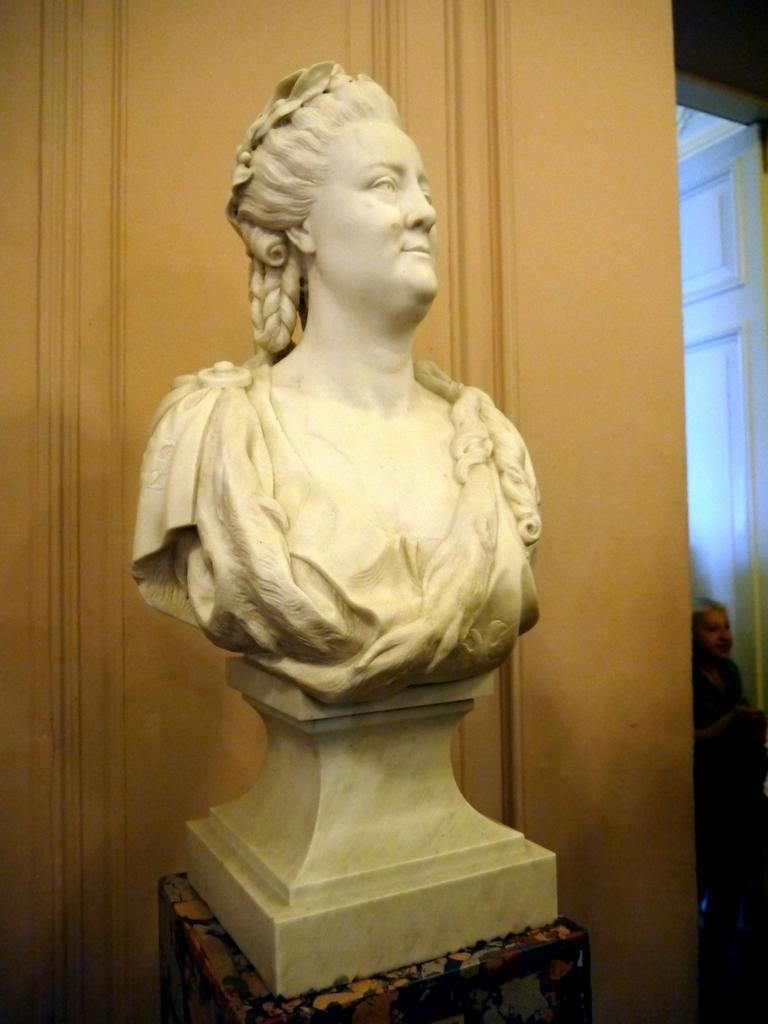Describe this image in one or two sentences. In the center of the picture there is a statue, behind the statue it is well. On the right there is a door and a person. 